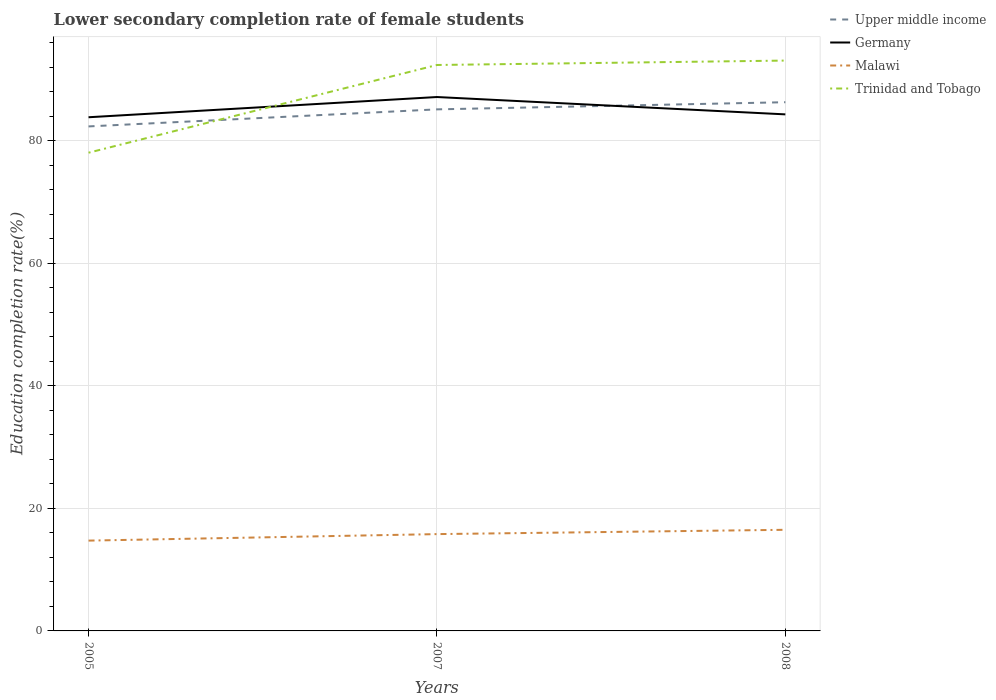How many different coloured lines are there?
Provide a short and direct response. 4. Across all years, what is the maximum lower secondary completion rate of female students in Trinidad and Tobago?
Give a very brief answer. 78.06. In which year was the lower secondary completion rate of female students in Upper middle income maximum?
Give a very brief answer. 2005. What is the total lower secondary completion rate of female students in Trinidad and Tobago in the graph?
Ensure brevity in your answer.  -0.72. What is the difference between the highest and the second highest lower secondary completion rate of female students in Upper middle income?
Make the answer very short. 3.95. What is the difference between the highest and the lowest lower secondary completion rate of female students in Malawi?
Ensure brevity in your answer.  2. Is the lower secondary completion rate of female students in Germany strictly greater than the lower secondary completion rate of female students in Upper middle income over the years?
Your response must be concise. No. How many years are there in the graph?
Keep it short and to the point. 3. Are the values on the major ticks of Y-axis written in scientific E-notation?
Provide a succinct answer. No. Does the graph contain any zero values?
Make the answer very short. No. Does the graph contain grids?
Provide a succinct answer. Yes. Where does the legend appear in the graph?
Your answer should be compact. Top right. How many legend labels are there?
Provide a succinct answer. 4. What is the title of the graph?
Give a very brief answer. Lower secondary completion rate of female students. Does "St. Vincent and the Grenadines" appear as one of the legend labels in the graph?
Ensure brevity in your answer.  No. What is the label or title of the X-axis?
Your answer should be very brief. Years. What is the label or title of the Y-axis?
Your answer should be very brief. Education completion rate(%). What is the Education completion rate(%) in Upper middle income in 2005?
Make the answer very short. 82.35. What is the Education completion rate(%) of Germany in 2005?
Give a very brief answer. 83.85. What is the Education completion rate(%) in Malawi in 2005?
Provide a short and direct response. 14.74. What is the Education completion rate(%) of Trinidad and Tobago in 2005?
Give a very brief answer. 78.06. What is the Education completion rate(%) of Upper middle income in 2007?
Give a very brief answer. 85.14. What is the Education completion rate(%) in Germany in 2007?
Provide a short and direct response. 87.15. What is the Education completion rate(%) of Malawi in 2007?
Your answer should be very brief. 15.8. What is the Education completion rate(%) in Trinidad and Tobago in 2007?
Ensure brevity in your answer.  92.38. What is the Education completion rate(%) in Upper middle income in 2008?
Provide a succinct answer. 86.31. What is the Education completion rate(%) in Germany in 2008?
Offer a very short reply. 84.32. What is the Education completion rate(%) in Malawi in 2008?
Your answer should be compact. 16.51. What is the Education completion rate(%) of Trinidad and Tobago in 2008?
Your answer should be very brief. 93.1. Across all years, what is the maximum Education completion rate(%) of Upper middle income?
Your answer should be very brief. 86.31. Across all years, what is the maximum Education completion rate(%) of Germany?
Give a very brief answer. 87.15. Across all years, what is the maximum Education completion rate(%) of Malawi?
Make the answer very short. 16.51. Across all years, what is the maximum Education completion rate(%) in Trinidad and Tobago?
Keep it short and to the point. 93.1. Across all years, what is the minimum Education completion rate(%) of Upper middle income?
Your response must be concise. 82.35. Across all years, what is the minimum Education completion rate(%) of Germany?
Give a very brief answer. 83.85. Across all years, what is the minimum Education completion rate(%) in Malawi?
Give a very brief answer. 14.74. Across all years, what is the minimum Education completion rate(%) of Trinidad and Tobago?
Keep it short and to the point. 78.06. What is the total Education completion rate(%) of Upper middle income in the graph?
Keep it short and to the point. 253.8. What is the total Education completion rate(%) in Germany in the graph?
Ensure brevity in your answer.  255.33. What is the total Education completion rate(%) in Malawi in the graph?
Your answer should be compact. 47.05. What is the total Education completion rate(%) in Trinidad and Tobago in the graph?
Provide a succinct answer. 263.55. What is the difference between the Education completion rate(%) in Upper middle income in 2005 and that in 2007?
Provide a succinct answer. -2.78. What is the difference between the Education completion rate(%) of Germany in 2005 and that in 2007?
Make the answer very short. -3.3. What is the difference between the Education completion rate(%) of Malawi in 2005 and that in 2007?
Keep it short and to the point. -1.06. What is the difference between the Education completion rate(%) in Trinidad and Tobago in 2005 and that in 2007?
Offer a very short reply. -14.32. What is the difference between the Education completion rate(%) of Upper middle income in 2005 and that in 2008?
Provide a succinct answer. -3.95. What is the difference between the Education completion rate(%) in Germany in 2005 and that in 2008?
Make the answer very short. -0.47. What is the difference between the Education completion rate(%) in Malawi in 2005 and that in 2008?
Your answer should be compact. -1.77. What is the difference between the Education completion rate(%) of Trinidad and Tobago in 2005 and that in 2008?
Provide a short and direct response. -15.04. What is the difference between the Education completion rate(%) in Upper middle income in 2007 and that in 2008?
Offer a very short reply. -1.17. What is the difference between the Education completion rate(%) in Germany in 2007 and that in 2008?
Provide a short and direct response. 2.83. What is the difference between the Education completion rate(%) of Malawi in 2007 and that in 2008?
Ensure brevity in your answer.  -0.7. What is the difference between the Education completion rate(%) of Trinidad and Tobago in 2007 and that in 2008?
Your answer should be very brief. -0.72. What is the difference between the Education completion rate(%) of Upper middle income in 2005 and the Education completion rate(%) of Germany in 2007?
Keep it short and to the point. -4.8. What is the difference between the Education completion rate(%) in Upper middle income in 2005 and the Education completion rate(%) in Malawi in 2007?
Keep it short and to the point. 66.55. What is the difference between the Education completion rate(%) of Upper middle income in 2005 and the Education completion rate(%) of Trinidad and Tobago in 2007?
Give a very brief answer. -10.03. What is the difference between the Education completion rate(%) of Germany in 2005 and the Education completion rate(%) of Malawi in 2007?
Your response must be concise. 68.05. What is the difference between the Education completion rate(%) in Germany in 2005 and the Education completion rate(%) in Trinidad and Tobago in 2007?
Make the answer very short. -8.53. What is the difference between the Education completion rate(%) in Malawi in 2005 and the Education completion rate(%) in Trinidad and Tobago in 2007?
Offer a terse response. -77.64. What is the difference between the Education completion rate(%) in Upper middle income in 2005 and the Education completion rate(%) in Germany in 2008?
Your response must be concise. -1.97. What is the difference between the Education completion rate(%) in Upper middle income in 2005 and the Education completion rate(%) in Malawi in 2008?
Your response must be concise. 65.85. What is the difference between the Education completion rate(%) in Upper middle income in 2005 and the Education completion rate(%) in Trinidad and Tobago in 2008?
Your answer should be very brief. -10.75. What is the difference between the Education completion rate(%) of Germany in 2005 and the Education completion rate(%) of Malawi in 2008?
Provide a short and direct response. 67.34. What is the difference between the Education completion rate(%) in Germany in 2005 and the Education completion rate(%) in Trinidad and Tobago in 2008?
Offer a very short reply. -9.25. What is the difference between the Education completion rate(%) of Malawi in 2005 and the Education completion rate(%) of Trinidad and Tobago in 2008?
Your answer should be very brief. -78.36. What is the difference between the Education completion rate(%) in Upper middle income in 2007 and the Education completion rate(%) in Germany in 2008?
Your response must be concise. 0.82. What is the difference between the Education completion rate(%) in Upper middle income in 2007 and the Education completion rate(%) in Malawi in 2008?
Offer a very short reply. 68.63. What is the difference between the Education completion rate(%) in Upper middle income in 2007 and the Education completion rate(%) in Trinidad and Tobago in 2008?
Give a very brief answer. -7.96. What is the difference between the Education completion rate(%) of Germany in 2007 and the Education completion rate(%) of Malawi in 2008?
Offer a very short reply. 70.65. What is the difference between the Education completion rate(%) in Germany in 2007 and the Education completion rate(%) in Trinidad and Tobago in 2008?
Make the answer very short. -5.95. What is the difference between the Education completion rate(%) of Malawi in 2007 and the Education completion rate(%) of Trinidad and Tobago in 2008?
Your response must be concise. -77.3. What is the average Education completion rate(%) of Upper middle income per year?
Provide a short and direct response. 84.6. What is the average Education completion rate(%) in Germany per year?
Your answer should be very brief. 85.11. What is the average Education completion rate(%) in Malawi per year?
Ensure brevity in your answer.  15.68. What is the average Education completion rate(%) of Trinidad and Tobago per year?
Give a very brief answer. 87.85. In the year 2005, what is the difference between the Education completion rate(%) of Upper middle income and Education completion rate(%) of Germany?
Offer a terse response. -1.5. In the year 2005, what is the difference between the Education completion rate(%) of Upper middle income and Education completion rate(%) of Malawi?
Give a very brief answer. 67.61. In the year 2005, what is the difference between the Education completion rate(%) in Upper middle income and Education completion rate(%) in Trinidad and Tobago?
Keep it short and to the point. 4.29. In the year 2005, what is the difference between the Education completion rate(%) of Germany and Education completion rate(%) of Malawi?
Keep it short and to the point. 69.11. In the year 2005, what is the difference between the Education completion rate(%) of Germany and Education completion rate(%) of Trinidad and Tobago?
Your response must be concise. 5.79. In the year 2005, what is the difference between the Education completion rate(%) of Malawi and Education completion rate(%) of Trinidad and Tobago?
Your answer should be very brief. -63.32. In the year 2007, what is the difference between the Education completion rate(%) in Upper middle income and Education completion rate(%) in Germany?
Keep it short and to the point. -2.01. In the year 2007, what is the difference between the Education completion rate(%) of Upper middle income and Education completion rate(%) of Malawi?
Keep it short and to the point. 69.33. In the year 2007, what is the difference between the Education completion rate(%) in Upper middle income and Education completion rate(%) in Trinidad and Tobago?
Provide a succinct answer. -7.24. In the year 2007, what is the difference between the Education completion rate(%) of Germany and Education completion rate(%) of Malawi?
Your response must be concise. 71.35. In the year 2007, what is the difference between the Education completion rate(%) in Germany and Education completion rate(%) in Trinidad and Tobago?
Your response must be concise. -5.23. In the year 2007, what is the difference between the Education completion rate(%) in Malawi and Education completion rate(%) in Trinidad and Tobago?
Give a very brief answer. -76.58. In the year 2008, what is the difference between the Education completion rate(%) in Upper middle income and Education completion rate(%) in Germany?
Offer a very short reply. 1.98. In the year 2008, what is the difference between the Education completion rate(%) in Upper middle income and Education completion rate(%) in Malawi?
Provide a succinct answer. 69.8. In the year 2008, what is the difference between the Education completion rate(%) of Upper middle income and Education completion rate(%) of Trinidad and Tobago?
Keep it short and to the point. -6.8. In the year 2008, what is the difference between the Education completion rate(%) of Germany and Education completion rate(%) of Malawi?
Offer a very short reply. 67.81. In the year 2008, what is the difference between the Education completion rate(%) of Germany and Education completion rate(%) of Trinidad and Tobago?
Offer a very short reply. -8.78. In the year 2008, what is the difference between the Education completion rate(%) of Malawi and Education completion rate(%) of Trinidad and Tobago?
Make the answer very short. -76.59. What is the ratio of the Education completion rate(%) in Upper middle income in 2005 to that in 2007?
Provide a succinct answer. 0.97. What is the ratio of the Education completion rate(%) in Germany in 2005 to that in 2007?
Give a very brief answer. 0.96. What is the ratio of the Education completion rate(%) of Malawi in 2005 to that in 2007?
Give a very brief answer. 0.93. What is the ratio of the Education completion rate(%) of Trinidad and Tobago in 2005 to that in 2007?
Keep it short and to the point. 0.84. What is the ratio of the Education completion rate(%) in Upper middle income in 2005 to that in 2008?
Provide a short and direct response. 0.95. What is the ratio of the Education completion rate(%) in Germany in 2005 to that in 2008?
Give a very brief answer. 0.99. What is the ratio of the Education completion rate(%) in Malawi in 2005 to that in 2008?
Keep it short and to the point. 0.89. What is the ratio of the Education completion rate(%) in Trinidad and Tobago in 2005 to that in 2008?
Offer a terse response. 0.84. What is the ratio of the Education completion rate(%) of Upper middle income in 2007 to that in 2008?
Give a very brief answer. 0.99. What is the ratio of the Education completion rate(%) in Germany in 2007 to that in 2008?
Your answer should be very brief. 1.03. What is the ratio of the Education completion rate(%) in Malawi in 2007 to that in 2008?
Ensure brevity in your answer.  0.96. What is the difference between the highest and the second highest Education completion rate(%) in Upper middle income?
Offer a terse response. 1.17. What is the difference between the highest and the second highest Education completion rate(%) in Germany?
Your response must be concise. 2.83. What is the difference between the highest and the second highest Education completion rate(%) in Malawi?
Make the answer very short. 0.7. What is the difference between the highest and the second highest Education completion rate(%) of Trinidad and Tobago?
Offer a terse response. 0.72. What is the difference between the highest and the lowest Education completion rate(%) in Upper middle income?
Keep it short and to the point. 3.95. What is the difference between the highest and the lowest Education completion rate(%) of Germany?
Your answer should be compact. 3.3. What is the difference between the highest and the lowest Education completion rate(%) in Malawi?
Make the answer very short. 1.77. What is the difference between the highest and the lowest Education completion rate(%) of Trinidad and Tobago?
Your answer should be compact. 15.04. 